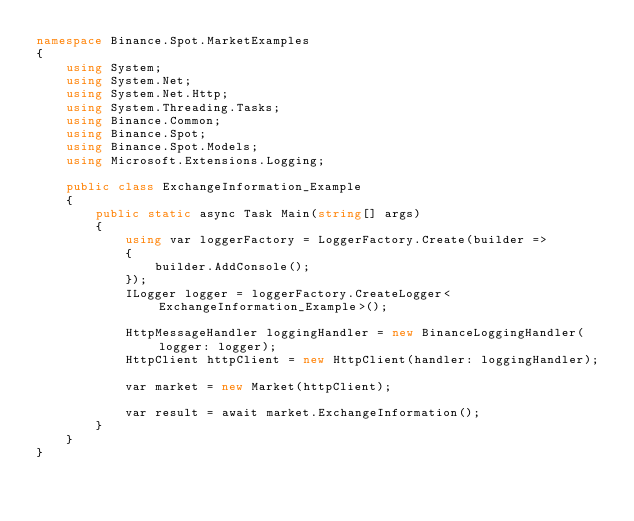<code> <loc_0><loc_0><loc_500><loc_500><_C#_>namespace Binance.Spot.MarketExamples
{
    using System;
    using System.Net;
    using System.Net.Http;
    using System.Threading.Tasks;
    using Binance.Common;
    using Binance.Spot;
    using Binance.Spot.Models;
    using Microsoft.Extensions.Logging;

    public class ExchangeInformation_Example
    {
        public static async Task Main(string[] args)
        {
            using var loggerFactory = LoggerFactory.Create(builder =>
            {
                builder.AddConsole();
            });
            ILogger logger = loggerFactory.CreateLogger<ExchangeInformation_Example>();

            HttpMessageHandler loggingHandler = new BinanceLoggingHandler(logger: logger);
            HttpClient httpClient = new HttpClient(handler: loggingHandler);

            var market = new Market(httpClient);

            var result = await market.ExchangeInformation();
        }
    }
}</code> 